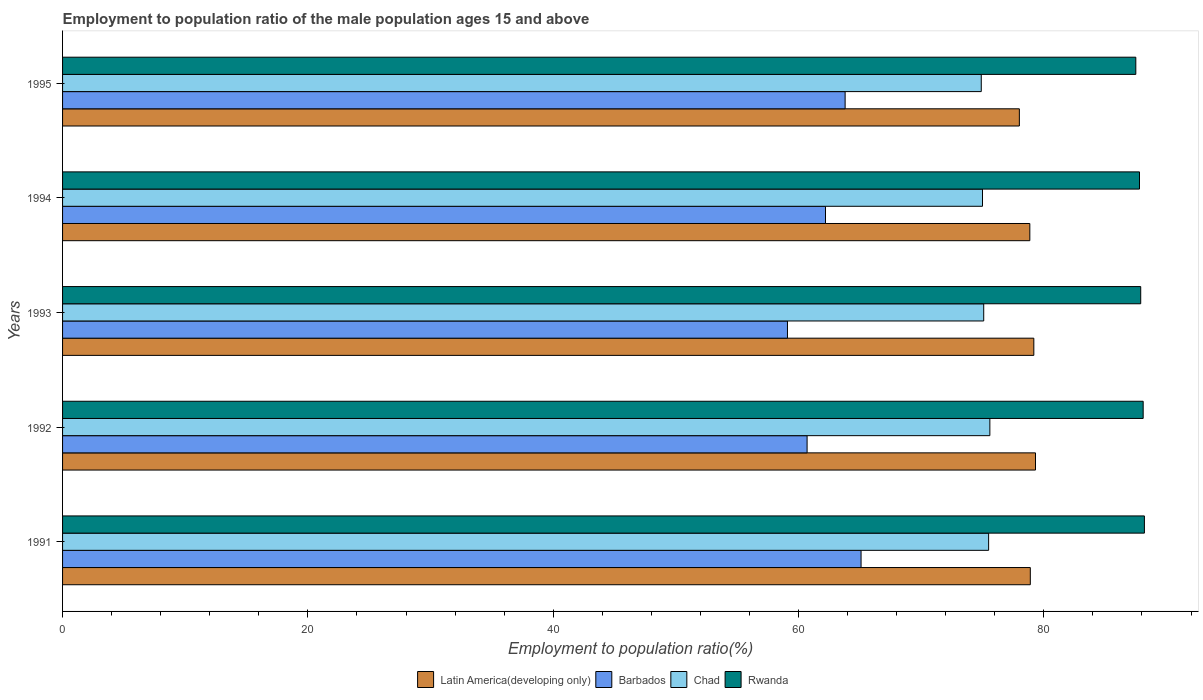Are the number of bars on each tick of the Y-axis equal?
Your answer should be compact. Yes. How many bars are there on the 3rd tick from the top?
Provide a short and direct response. 4. How many bars are there on the 5th tick from the bottom?
Offer a terse response. 4. What is the label of the 5th group of bars from the top?
Give a very brief answer. 1991. What is the employment to population ratio in Chad in 1994?
Offer a terse response. 75. Across all years, what is the maximum employment to population ratio in Rwanda?
Provide a short and direct response. 88.2. Across all years, what is the minimum employment to population ratio in Barbados?
Ensure brevity in your answer.  59.1. In which year was the employment to population ratio in Latin America(developing only) maximum?
Offer a terse response. 1992. In which year was the employment to population ratio in Latin America(developing only) minimum?
Make the answer very short. 1995. What is the total employment to population ratio in Barbados in the graph?
Your answer should be compact. 310.9. What is the difference between the employment to population ratio in Latin America(developing only) in 1991 and that in 1995?
Your answer should be compact. 0.89. What is the difference between the employment to population ratio in Latin America(developing only) in 1994 and the employment to population ratio in Chad in 1992?
Provide a short and direct response. 3.26. What is the average employment to population ratio in Chad per year?
Make the answer very short. 75.22. In the year 1994, what is the difference between the employment to population ratio in Chad and employment to population ratio in Barbados?
Offer a terse response. 12.8. What is the ratio of the employment to population ratio in Rwanda in 1993 to that in 1995?
Give a very brief answer. 1. What is the difference between the highest and the second highest employment to population ratio in Rwanda?
Give a very brief answer. 0.1. What is the difference between the highest and the lowest employment to population ratio in Barbados?
Provide a succinct answer. 6. In how many years, is the employment to population ratio in Latin America(developing only) greater than the average employment to population ratio in Latin America(developing only) taken over all years?
Offer a terse response. 4. Is the sum of the employment to population ratio in Barbados in 1991 and 1994 greater than the maximum employment to population ratio in Rwanda across all years?
Your response must be concise. Yes. Is it the case that in every year, the sum of the employment to population ratio in Chad and employment to population ratio in Latin America(developing only) is greater than the sum of employment to population ratio in Barbados and employment to population ratio in Rwanda?
Provide a short and direct response. Yes. What does the 2nd bar from the top in 1991 represents?
Give a very brief answer. Chad. What does the 4th bar from the bottom in 1991 represents?
Ensure brevity in your answer.  Rwanda. How many bars are there?
Make the answer very short. 20. What is the difference between two consecutive major ticks on the X-axis?
Your answer should be compact. 20. Does the graph contain any zero values?
Your answer should be compact. No. How are the legend labels stacked?
Provide a short and direct response. Horizontal. What is the title of the graph?
Your answer should be very brief. Employment to population ratio of the male population ages 15 and above. What is the label or title of the Y-axis?
Your answer should be compact. Years. What is the Employment to population ratio(%) in Latin America(developing only) in 1991?
Offer a terse response. 78.9. What is the Employment to population ratio(%) of Barbados in 1991?
Make the answer very short. 65.1. What is the Employment to population ratio(%) of Chad in 1991?
Provide a succinct answer. 75.5. What is the Employment to population ratio(%) in Rwanda in 1991?
Offer a terse response. 88.2. What is the Employment to population ratio(%) in Latin America(developing only) in 1992?
Keep it short and to the point. 79.32. What is the Employment to population ratio(%) in Barbados in 1992?
Give a very brief answer. 60.7. What is the Employment to population ratio(%) of Chad in 1992?
Your answer should be compact. 75.6. What is the Employment to population ratio(%) of Rwanda in 1992?
Your answer should be compact. 88.1. What is the Employment to population ratio(%) in Latin America(developing only) in 1993?
Your answer should be compact. 79.19. What is the Employment to population ratio(%) of Barbados in 1993?
Your response must be concise. 59.1. What is the Employment to population ratio(%) of Chad in 1993?
Offer a terse response. 75.1. What is the Employment to population ratio(%) of Rwanda in 1993?
Ensure brevity in your answer.  87.9. What is the Employment to population ratio(%) in Latin America(developing only) in 1994?
Give a very brief answer. 78.86. What is the Employment to population ratio(%) in Barbados in 1994?
Offer a very short reply. 62.2. What is the Employment to population ratio(%) of Chad in 1994?
Keep it short and to the point. 75. What is the Employment to population ratio(%) in Rwanda in 1994?
Ensure brevity in your answer.  87.8. What is the Employment to population ratio(%) in Latin America(developing only) in 1995?
Provide a succinct answer. 78.01. What is the Employment to population ratio(%) of Barbados in 1995?
Your response must be concise. 63.8. What is the Employment to population ratio(%) of Chad in 1995?
Give a very brief answer. 74.9. What is the Employment to population ratio(%) in Rwanda in 1995?
Your answer should be very brief. 87.5. Across all years, what is the maximum Employment to population ratio(%) of Latin America(developing only)?
Provide a short and direct response. 79.32. Across all years, what is the maximum Employment to population ratio(%) in Barbados?
Give a very brief answer. 65.1. Across all years, what is the maximum Employment to population ratio(%) of Chad?
Your answer should be compact. 75.6. Across all years, what is the maximum Employment to population ratio(%) of Rwanda?
Offer a terse response. 88.2. Across all years, what is the minimum Employment to population ratio(%) in Latin America(developing only)?
Make the answer very short. 78.01. Across all years, what is the minimum Employment to population ratio(%) of Barbados?
Offer a terse response. 59.1. Across all years, what is the minimum Employment to population ratio(%) of Chad?
Ensure brevity in your answer.  74.9. Across all years, what is the minimum Employment to population ratio(%) of Rwanda?
Ensure brevity in your answer.  87.5. What is the total Employment to population ratio(%) of Latin America(developing only) in the graph?
Your response must be concise. 394.27. What is the total Employment to population ratio(%) in Barbados in the graph?
Offer a very short reply. 310.9. What is the total Employment to population ratio(%) in Chad in the graph?
Offer a terse response. 376.1. What is the total Employment to population ratio(%) of Rwanda in the graph?
Keep it short and to the point. 439.5. What is the difference between the Employment to population ratio(%) of Latin America(developing only) in 1991 and that in 1992?
Provide a succinct answer. -0.42. What is the difference between the Employment to population ratio(%) of Latin America(developing only) in 1991 and that in 1993?
Provide a succinct answer. -0.29. What is the difference between the Employment to population ratio(%) of Chad in 1991 and that in 1993?
Provide a short and direct response. 0.4. What is the difference between the Employment to population ratio(%) in Latin America(developing only) in 1991 and that in 1994?
Provide a short and direct response. 0.04. What is the difference between the Employment to population ratio(%) of Barbados in 1991 and that in 1994?
Provide a succinct answer. 2.9. What is the difference between the Employment to population ratio(%) of Chad in 1991 and that in 1994?
Offer a terse response. 0.5. What is the difference between the Employment to population ratio(%) of Latin America(developing only) in 1991 and that in 1995?
Make the answer very short. 0.89. What is the difference between the Employment to population ratio(%) of Barbados in 1991 and that in 1995?
Your response must be concise. 1.3. What is the difference between the Employment to population ratio(%) in Latin America(developing only) in 1992 and that in 1993?
Your response must be concise. 0.14. What is the difference between the Employment to population ratio(%) of Barbados in 1992 and that in 1993?
Give a very brief answer. 1.6. What is the difference between the Employment to population ratio(%) in Rwanda in 1992 and that in 1993?
Give a very brief answer. 0.2. What is the difference between the Employment to population ratio(%) of Latin America(developing only) in 1992 and that in 1994?
Ensure brevity in your answer.  0.46. What is the difference between the Employment to population ratio(%) in Barbados in 1992 and that in 1994?
Ensure brevity in your answer.  -1.5. What is the difference between the Employment to population ratio(%) in Rwanda in 1992 and that in 1994?
Make the answer very short. 0.3. What is the difference between the Employment to population ratio(%) of Latin America(developing only) in 1992 and that in 1995?
Keep it short and to the point. 1.32. What is the difference between the Employment to population ratio(%) of Chad in 1992 and that in 1995?
Give a very brief answer. 0.7. What is the difference between the Employment to population ratio(%) of Rwanda in 1992 and that in 1995?
Offer a very short reply. 0.6. What is the difference between the Employment to population ratio(%) of Latin America(developing only) in 1993 and that in 1994?
Your answer should be very brief. 0.33. What is the difference between the Employment to population ratio(%) of Barbados in 1993 and that in 1994?
Your answer should be very brief. -3.1. What is the difference between the Employment to population ratio(%) of Chad in 1993 and that in 1994?
Provide a short and direct response. 0.1. What is the difference between the Employment to population ratio(%) of Rwanda in 1993 and that in 1994?
Provide a short and direct response. 0.1. What is the difference between the Employment to population ratio(%) of Latin America(developing only) in 1993 and that in 1995?
Your response must be concise. 1.18. What is the difference between the Employment to population ratio(%) of Barbados in 1993 and that in 1995?
Make the answer very short. -4.7. What is the difference between the Employment to population ratio(%) of Chad in 1993 and that in 1995?
Give a very brief answer. 0.2. What is the difference between the Employment to population ratio(%) in Rwanda in 1993 and that in 1995?
Provide a succinct answer. 0.4. What is the difference between the Employment to population ratio(%) of Latin America(developing only) in 1994 and that in 1995?
Provide a succinct answer. 0.85. What is the difference between the Employment to population ratio(%) in Barbados in 1994 and that in 1995?
Make the answer very short. -1.6. What is the difference between the Employment to population ratio(%) of Chad in 1994 and that in 1995?
Your answer should be very brief. 0.1. What is the difference between the Employment to population ratio(%) of Rwanda in 1994 and that in 1995?
Your answer should be compact. 0.3. What is the difference between the Employment to population ratio(%) in Latin America(developing only) in 1991 and the Employment to population ratio(%) in Barbados in 1992?
Provide a short and direct response. 18.2. What is the difference between the Employment to population ratio(%) of Latin America(developing only) in 1991 and the Employment to population ratio(%) of Chad in 1992?
Your answer should be very brief. 3.3. What is the difference between the Employment to population ratio(%) in Latin America(developing only) in 1991 and the Employment to population ratio(%) in Rwanda in 1992?
Offer a very short reply. -9.2. What is the difference between the Employment to population ratio(%) of Barbados in 1991 and the Employment to population ratio(%) of Chad in 1992?
Your answer should be compact. -10.5. What is the difference between the Employment to population ratio(%) of Chad in 1991 and the Employment to population ratio(%) of Rwanda in 1992?
Provide a succinct answer. -12.6. What is the difference between the Employment to population ratio(%) of Latin America(developing only) in 1991 and the Employment to population ratio(%) of Barbados in 1993?
Provide a succinct answer. 19.8. What is the difference between the Employment to population ratio(%) of Latin America(developing only) in 1991 and the Employment to population ratio(%) of Chad in 1993?
Your response must be concise. 3.8. What is the difference between the Employment to population ratio(%) in Latin America(developing only) in 1991 and the Employment to population ratio(%) in Rwanda in 1993?
Make the answer very short. -9. What is the difference between the Employment to population ratio(%) of Barbados in 1991 and the Employment to population ratio(%) of Chad in 1993?
Ensure brevity in your answer.  -10. What is the difference between the Employment to population ratio(%) of Barbados in 1991 and the Employment to population ratio(%) of Rwanda in 1993?
Offer a very short reply. -22.8. What is the difference between the Employment to population ratio(%) in Latin America(developing only) in 1991 and the Employment to population ratio(%) in Barbados in 1994?
Keep it short and to the point. 16.7. What is the difference between the Employment to population ratio(%) in Latin America(developing only) in 1991 and the Employment to population ratio(%) in Chad in 1994?
Make the answer very short. 3.9. What is the difference between the Employment to population ratio(%) in Latin America(developing only) in 1991 and the Employment to population ratio(%) in Rwanda in 1994?
Give a very brief answer. -8.9. What is the difference between the Employment to population ratio(%) in Barbados in 1991 and the Employment to population ratio(%) in Rwanda in 1994?
Provide a succinct answer. -22.7. What is the difference between the Employment to population ratio(%) in Chad in 1991 and the Employment to population ratio(%) in Rwanda in 1994?
Provide a short and direct response. -12.3. What is the difference between the Employment to population ratio(%) of Latin America(developing only) in 1991 and the Employment to population ratio(%) of Barbados in 1995?
Make the answer very short. 15.1. What is the difference between the Employment to population ratio(%) in Latin America(developing only) in 1991 and the Employment to population ratio(%) in Chad in 1995?
Your response must be concise. 4. What is the difference between the Employment to population ratio(%) in Latin America(developing only) in 1991 and the Employment to population ratio(%) in Rwanda in 1995?
Give a very brief answer. -8.6. What is the difference between the Employment to population ratio(%) in Barbados in 1991 and the Employment to population ratio(%) in Rwanda in 1995?
Keep it short and to the point. -22.4. What is the difference between the Employment to population ratio(%) in Latin America(developing only) in 1992 and the Employment to population ratio(%) in Barbados in 1993?
Keep it short and to the point. 20.22. What is the difference between the Employment to population ratio(%) of Latin America(developing only) in 1992 and the Employment to population ratio(%) of Chad in 1993?
Provide a succinct answer. 4.22. What is the difference between the Employment to population ratio(%) of Latin America(developing only) in 1992 and the Employment to population ratio(%) of Rwanda in 1993?
Your response must be concise. -8.58. What is the difference between the Employment to population ratio(%) in Barbados in 1992 and the Employment to population ratio(%) in Chad in 1993?
Keep it short and to the point. -14.4. What is the difference between the Employment to population ratio(%) in Barbados in 1992 and the Employment to population ratio(%) in Rwanda in 1993?
Your answer should be very brief. -27.2. What is the difference between the Employment to population ratio(%) of Latin America(developing only) in 1992 and the Employment to population ratio(%) of Barbados in 1994?
Give a very brief answer. 17.12. What is the difference between the Employment to population ratio(%) in Latin America(developing only) in 1992 and the Employment to population ratio(%) in Chad in 1994?
Your response must be concise. 4.32. What is the difference between the Employment to population ratio(%) of Latin America(developing only) in 1992 and the Employment to population ratio(%) of Rwanda in 1994?
Give a very brief answer. -8.48. What is the difference between the Employment to population ratio(%) of Barbados in 1992 and the Employment to population ratio(%) of Chad in 1994?
Make the answer very short. -14.3. What is the difference between the Employment to population ratio(%) in Barbados in 1992 and the Employment to population ratio(%) in Rwanda in 1994?
Offer a very short reply. -27.1. What is the difference between the Employment to population ratio(%) of Chad in 1992 and the Employment to population ratio(%) of Rwanda in 1994?
Your answer should be very brief. -12.2. What is the difference between the Employment to population ratio(%) of Latin America(developing only) in 1992 and the Employment to population ratio(%) of Barbados in 1995?
Offer a very short reply. 15.52. What is the difference between the Employment to population ratio(%) of Latin America(developing only) in 1992 and the Employment to population ratio(%) of Chad in 1995?
Your answer should be compact. 4.42. What is the difference between the Employment to population ratio(%) of Latin America(developing only) in 1992 and the Employment to population ratio(%) of Rwanda in 1995?
Your response must be concise. -8.18. What is the difference between the Employment to population ratio(%) of Barbados in 1992 and the Employment to population ratio(%) of Chad in 1995?
Provide a succinct answer. -14.2. What is the difference between the Employment to population ratio(%) of Barbados in 1992 and the Employment to population ratio(%) of Rwanda in 1995?
Your answer should be compact. -26.8. What is the difference between the Employment to population ratio(%) of Chad in 1992 and the Employment to population ratio(%) of Rwanda in 1995?
Provide a short and direct response. -11.9. What is the difference between the Employment to population ratio(%) in Latin America(developing only) in 1993 and the Employment to population ratio(%) in Barbados in 1994?
Make the answer very short. 16.99. What is the difference between the Employment to population ratio(%) in Latin America(developing only) in 1993 and the Employment to population ratio(%) in Chad in 1994?
Keep it short and to the point. 4.19. What is the difference between the Employment to population ratio(%) of Latin America(developing only) in 1993 and the Employment to population ratio(%) of Rwanda in 1994?
Provide a short and direct response. -8.61. What is the difference between the Employment to population ratio(%) of Barbados in 1993 and the Employment to population ratio(%) of Chad in 1994?
Ensure brevity in your answer.  -15.9. What is the difference between the Employment to population ratio(%) in Barbados in 1993 and the Employment to population ratio(%) in Rwanda in 1994?
Keep it short and to the point. -28.7. What is the difference between the Employment to population ratio(%) in Chad in 1993 and the Employment to population ratio(%) in Rwanda in 1994?
Give a very brief answer. -12.7. What is the difference between the Employment to population ratio(%) in Latin America(developing only) in 1993 and the Employment to population ratio(%) in Barbados in 1995?
Offer a terse response. 15.39. What is the difference between the Employment to population ratio(%) of Latin America(developing only) in 1993 and the Employment to population ratio(%) of Chad in 1995?
Make the answer very short. 4.29. What is the difference between the Employment to population ratio(%) of Latin America(developing only) in 1993 and the Employment to population ratio(%) of Rwanda in 1995?
Your response must be concise. -8.31. What is the difference between the Employment to population ratio(%) of Barbados in 1993 and the Employment to population ratio(%) of Chad in 1995?
Provide a succinct answer. -15.8. What is the difference between the Employment to population ratio(%) of Barbados in 1993 and the Employment to population ratio(%) of Rwanda in 1995?
Make the answer very short. -28.4. What is the difference between the Employment to population ratio(%) in Latin America(developing only) in 1994 and the Employment to population ratio(%) in Barbados in 1995?
Make the answer very short. 15.06. What is the difference between the Employment to population ratio(%) in Latin America(developing only) in 1994 and the Employment to population ratio(%) in Chad in 1995?
Your response must be concise. 3.96. What is the difference between the Employment to population ratio(%) in Latin America(developing only) in 1994 and the Employment to population ratio(%) in Rwanda in 1995?
Your answer should be compact. -8.64. What is the difference between the Employment to population ratio(%) of Barbados in 1994 and the Employment to population ratio(%) of Rwanda in 1995?
Keep it short and to the point. -25.3. What is the difference between the Employment to population ratio(%) of Chad in 1994 and the Employment to population ratio(%) of Rwanda in 1995?
Keep it short and to the point. -12.5. What is the average Employment to population ratio(%) in Latin America(developing only) per year?
Give a very brief answer. 78.85. What is the average Employment to population ratio(%) in Barbados per year?
Ensure brevity in your answer.  62.18. What is the average Employment to population ratio(%) in Chad per year?
Give a very brief answer. 75.22. What is the average Employment to population ratio(%) in Rwanda per year?
Give a very brief answer. 87.9. In the year 1991, what is the difference between the Employment to population ratio(%) in Latin America(developing only) and Employment to population ratio(%) in Barbados?
Your response must be concise. 13.8. In the year 1991, what is the difference between the Employment to population ratio(%) in Latin America(developing only) and Employment to population ratio(%) in Chad?
Offer a terse response. 3.4. In the year 1991, what is the difference between the Employment to population ratio(%) of Latin America(developing only) and Employment to population ratio(%) of Rwanda?
Keep it short and to the point. -9.3. In the year 1991, what is the difference between the Employment to population ratio(%) of Barbados and Employment to population ratio(%) of Chad?
Ensure brevity in your answer.  -10.4. In the year 1991, what is the difference between the Employment to population ratio(%) of Barbados and Employment to population ratio(%) of Rwanda?
Your response must be concise. -23.1. In the year 1991, what is the difference between the Employment to population ratio(%) in Chad and Employment to population ratio(%) in Rwanda?
Make the answer very short. -12.7. In the year 1992, what is the difference between the Employment to population ratio(%) in Latin America(developing only) and Employment to population ratio(%) in Barbados?
Ensure brevity in your answer.  18.62. In the year 1992, what is the difference between the Employment to population ratio(%) in Latin America(developing only) and Employment to population ratio(%) in Chad?
Make the answer very short. 3.72. In the year 1992, what is the difference between the Employment to population ratio(%) in Latin America(developing only) and Employment to population ratio(%) in Rwanda?
Offer a very short reply. -8.78. In the year 1992, what is the difference between the Employment to population ratio(%) of Barbados and Employment to population ratio(%) of Chad?
Ensure brevity in your answer.  -14.9. In the year 1992, what is the difference between the Employment to population ratio(%) in Barbados and Employment to population ratio(%) in Rwanda?
Provide a succinct answer. -27.4. In the year 1993, what is the difference between the Employment to population ratio(%) in Latin America(developing only) and Employment to population ratio(%) in Barbados?
Ensure brevity in your answer.  20.09. In the year 1993, what is the difference between the Employment to population ratio(%) in Latin America(developing only) and Employment to population ratio(%) in Chad?
Your answer should be very brief. 4.09. In the year 1993, what is the difference between the Employment to population ratio(%) of Latin America(developing only) and Employment to population ratio(%) of Rwanda?
Give a very brief answer. -8.71. In the year 1993, what is the difference between the Employment to population ratio(%) in Barbados and Employment to population ratio(%) in Chad?
Offer a very short reply. -16. In the year 1993, what is the difference between the Employment to population ratio(%) of Barbados and Employment to population ratio(%) of Rwanda?
Your answer should be very brief. -28.8. In the year 1993, what is the difference between the Employment to population ratio(%) in Chad and Employment to population ratio(%) in Rwanda?
Offer a very short reply. -12.8. In the year 1994, what is the difference between the Employment to population ratio(%) of Latin America(developing only) and Employment to population ratio(%) of Barbados?
Give a very brief answer. 16.66. In the year 1994, what is the difference between the Employment to population ratio(%) of Latin America(developing only) and Employment to population ratio(%) of Chad?
Your answer should be compact. 3.86. In the year 1994, what is the difference between the Employment to population ratio(%) of Latin America(developing only) and Employment to population ratio(%) of Rwanda?
Offer a very short reply. -8.94. In the year 1994, what is the difference between the Employment to population ratio(%) in Barbados and Employment to population ratio(%) in Rwanda?
Your response must be concise. -25.6. In the year 1995, what is the difference between the Employment to population ratio(%) of Latin America(developing only) and Employment to population ratio(%) of Barbados?
Ensure brevity in your answer.  14.21. In the year 1995, what is the difference between the Employment to population ratio(%) in Latin America(developing only) and Employment to population ratio(%) in Chad?
Provide a short and direct response. 3.11. In the year 1995, what is the difference between the Employment to population ratio(%) of Latin America(developing only) and Employment to population ratio(%) of Rwanda?
Your answer should be compact. -9.49. In the year 1995, what is the difference between the Employment to population ratio(%) in Barbados and Employment to population ratio(%) in Rwanda?
Provide a succinct answer. -23.7. In the year 1995, what is the difference between the Employment to population ratio(%) in Chad and Employment to population ratio(%) in Rwanda?
Provide a succinct answer. -12.6. What is the ratio of the Employment to population ratio(%) of Barbados in 1991 to that in 1992?
Make the answer very short. 1.07. What is the ratio of the Employment to population ratio(%) in Chad in 1991 to that in 1992?
Offer a very short reply. 1. What is the ratio of the Employment to population ratio(%) of Rwanda in 1991 to that in 1992?
Give a very brief answer. 1. What is the ratio of the Employment to population ratio(%) in Latin America(developing only) in 1991 to that in 1993?
Keep it short and to the point. 1. What is the ratio of the Employment to population ratio(%) of Barbados in 1991 to that in 1993?
Your answer should be very brief. 1.1. What is the ratio of the Employment to population ratio(%) in Rwanda in 1991 to that in 1993?
Provide a short and direct response. 1. What is the ratio of the Employment to population ratio(%) in Barbados in 1991 to that in 1994?
Offer a very short reply. 1.05. What is the ratio of the Employment to population ratio(%) of Chad in 1991 to that in 1994?
Provide a short and direct response. 1.01. What is the ratio of the Employment to population ratio(%) of Latin America(developing only) in 1991 to that in 1995?
Make the answer very short. 1.01. What is the ratio of the Employment to population ratio(%) of Barbados in 1991 to that in 1995?
Provide a short and direct response. 1.02. What is the ratio of the Employment to population ratio(%) in Chad in 1991 to that in 1995?
Offer a very short reply. 1.01. What is the ratio of the Employment to population ratio(%) in Barbados in 1992 to that in 1993?
Offer a very short reply. 1.03. What is the ratio of the Employment to population ratio(%) of Chad in 1992 to that in 1993?
Offer a terse response. 1.01. What is the ratio of the Employment to population ratio(%) of Latin America(developing only) in 1992 to that in 1994?
Provide a succinct answer. 1.01. What is the ratio of the Employment to population ratio(%) of Barbados in 1992 to that in 1994?
Your answer should be compact. 0.98. What is the ratio of the Employment to population ratio(%) in Latin America(developing only) in 1992 to that in 1995?
Make the answer very short. 1.02. What is the ratio of the Employment to population ratio(%) of Barbados in 1992 to that in 1995?
Make the answer very short. 0.95. What is the ratio of the Employment to population ratio(%) of Chad in 1992 to that in 1995?
Offer a very short reply. 1.01. What is the ratio of the Employment to population ratio(%) of Rwanda in 1992 to that in 1995?
Offer a terse response. 1.01. What is the ratio of the Employment to population ratio(%) in Barbados in 1993 to that in 1994?
Give a very brief answer. 0.95. What is the ratio of the Employment to population ratio(%) of Latin America(developing only) in 1993 to that in 1995?
Your answer should be compact. 1.02. What is the ratio of the Employment to population ratio(%) in Barbados in 1993 to that in 1995?
Give a very brief answer. 0.93. What is the ratio of the Employment to population ratio(%) in Chad in 1993 to that in 1995?
Offer a very short reply. 1. What is the ratio of the Employment to population ratio(%) in Rwanda in 1993 to that in 1995?
Ensure brevity in your answer.  1. What is the ratio of the Employment to population ratio(%) of Latin America(developing only) in 1994 to that in 1995?
Provide a succinct answer. 1.01. What is the ratio of the Employment to population ratio(%) of Barbados in 1994 to that in 1995?
Offer a very short reply. 0.97. What is the ratio of the Employment to population ratio(%) of Rwanda in 1994 to that in 1995?
Offer a very short reply. 1. What is the difference between the highest and the second highest Employment to population ratio(%) in Latin America(developing only)?
Make the answer very short. 0.14. What is the difference between the highest and the second highest Employment to population ratio(%) in Chad?
Ensure brevity in your answer.  0.1. What is the difference between the highest and the lowest Employment to population ratio(%) of Latin America(developing only)?
Keep it short and to the point. 1.32. What is the difference between the highest and the lowest Employment to population ratio(%) of Chad?
Keep it short and to the point. 0.7. What is the difference between the highest and the lowest Employment to population ratio(%) in Rwanda?
Give a very brief answer. 0.7. 